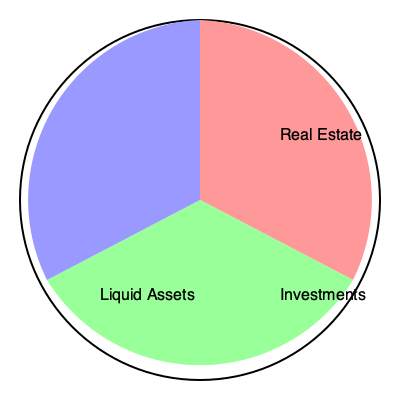In a high-profile divorce case, you're presented with a pie chart showing the distribution of marital assets. The chart is divided into three sections: Real Estate, Investments, and Liquid Assets. Which asset category represents the largest share of the marital estate? To determine the largest share in the pie chart, we need to compare the sizes of the three sectors:

1. Real Estate (red sector): This sector spans from 12 o'clock to about 4 o'clock, covering approximately 120 degrees.

2. Investments (green sector): This sector spans from about 4 o'clock to 8 o'clock, covering approximately 120 degrees.

3. Liquid Assets (blue sector): This sector spans from 8 o'clock back to 12 o'clock, covering approximately 120 degrees.

In a complete circle, there are 360 degrees. Each sector in this pie chart covers about 120 degrees, which is exactly one-third of the circle (120 ÷ 360 = 1/3).

Since all three sectors are equal in size, they each represent an equal share of the marital estate. However, the question asks for the largest share, so we must conclude that there is no single largest share; all categories are equal.

As an experienced divorce attorney, it's crucial to recognize this equal distribution, as it may impact negotiations and the overall strategy for asset division in the divorce proceedings.
Answer: No single largest share; all categories are equal. 